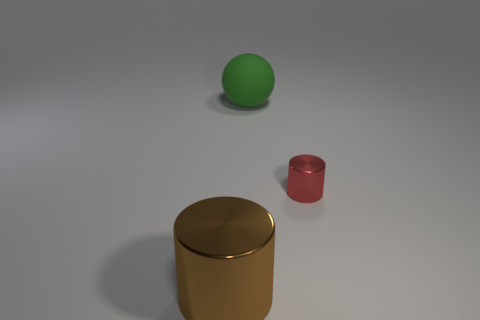Add 1 cyan blocks. How many objects exist? 4 Subtract all brown cylinders. How many cylinders are left? 1 Subtract 1 cylinders. How many cylinders are left? 1 Subtract all balls. How many objects are left? 2 Subtract 0 gray balls. How many objects are left? 3 Subtract all red cylinders. Subtract all purple spheres. How many cylinders are left? 1 Subtract all gray blocks. How many blue cylinders are left? 0 Subtract all tiny cyan things. Subtract all brown cylinders. How many objects are left? 2 Add 2 big brown things. How many big brown things are left? 3 Add 3 small purple rubber blocks. How many small purple rubber blocks exist? 3 